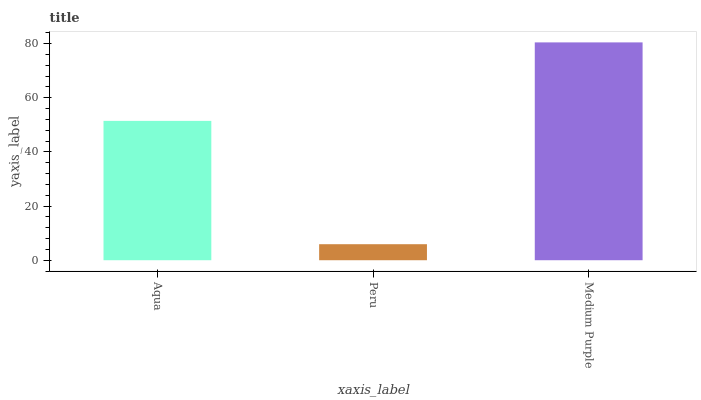Is Medium Purple the minimum?
Answer yes or no. No. Is Peru the maximum?
Answer yes or no. No. Is Medium Purple greater than Peru?
Answer yes or no. Yes. Is Peru less than Medium Purple?
Answer yes or no. Yes. Is Peru greater than Medium Purple?
Answer yes or no. No. Is Medium Purple less than Peru?
Answer yes or no. No. Is Aqua the high median?
Answer yes or no. Yes. Is Aqua the low median?
Answer yes or no. Yes. Is Medium Purple the high median?
Answer yes or no. No. Is Medium Purple the low median?
Answer yes or no. No. 